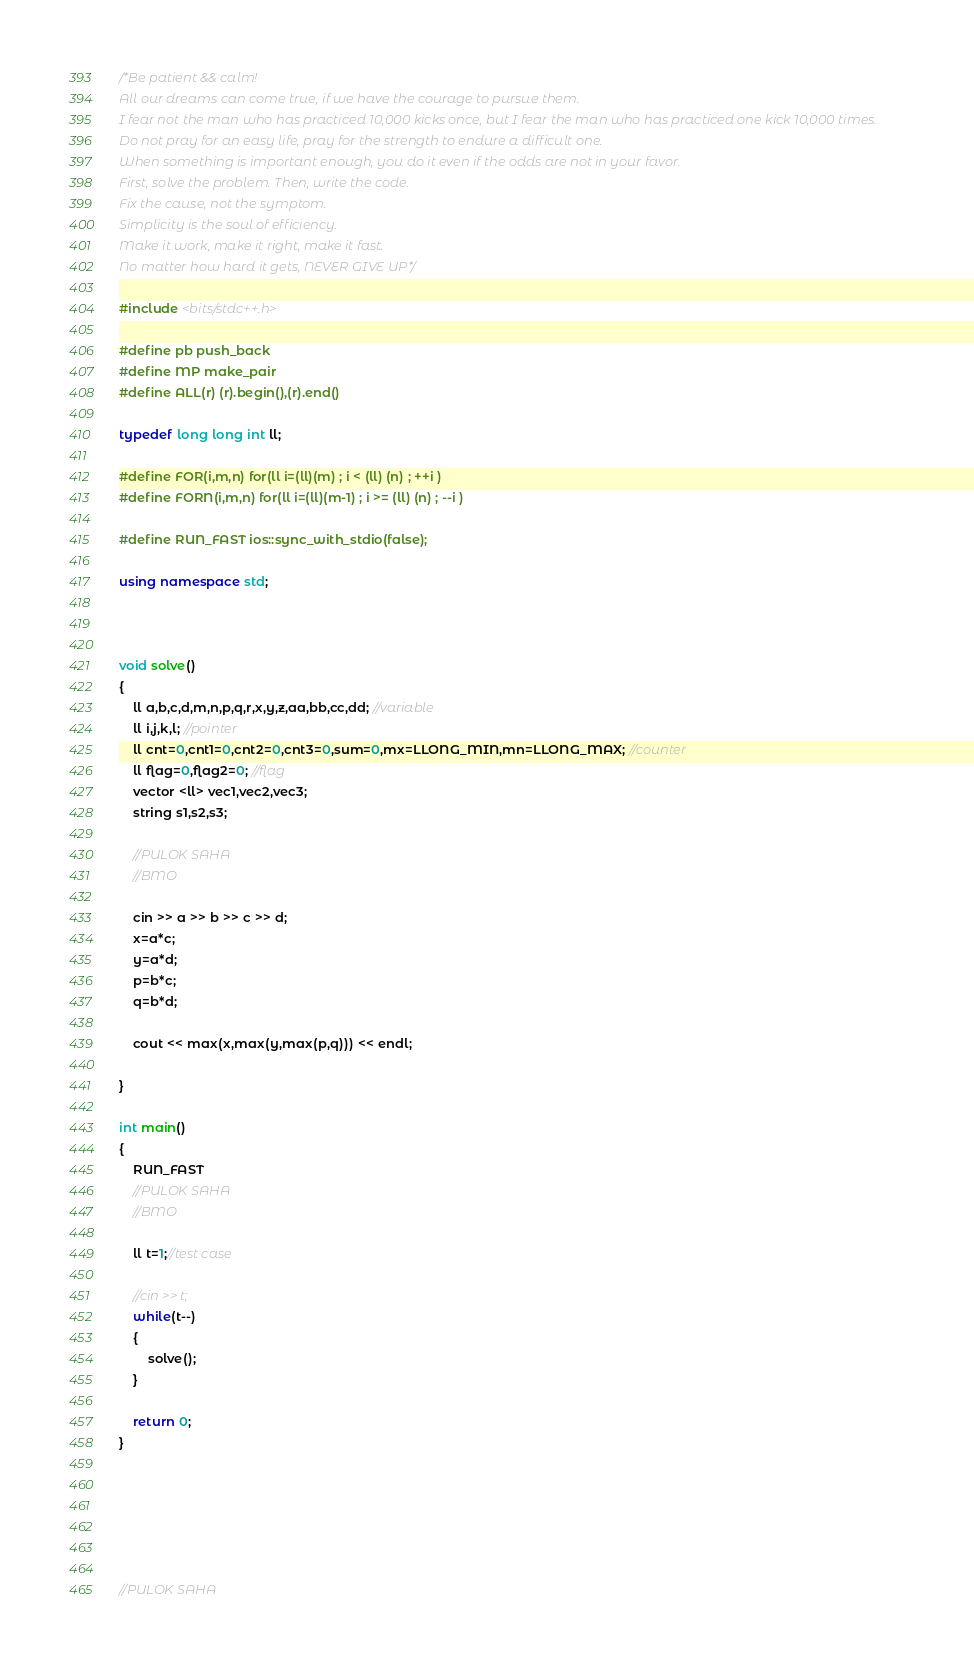Convert code to text. <code><loc_0><loc_0><loc_500><loc_500><_C++_>/*Be patient && calm!
All our dreams can come true, if we have the courage to pursue them.
I fear not the man who has practiced 10,000 kicks once, but I fear the man who has practiced one kick 10,000 times.
Do not pray for an easy life, pray for the strength to endure a difficult one.
When something is important enough, you do it even if the odds are not in your favor.
First, solve the problem. Then, write the code.
Fix the cause, not the symptom.
Simplicity is the soul of efficiency.
Make it work, make it right, make it fast.
No matter how hard it gets, NEVER GIVE UP*/

#include <bits/stdc++.h>

#define pb push_back
#define MP make_pair
#define ALL(r) (r).begin(),(r).end()

typedef long long int ll;

#define FOR(i,m,n) for(ll i=(ll)(m) ; i < (ll) (n) ; ++i )
#define FORN(i,m,n) for(ll i=(ll)(m-1) ; i >= (ll) (n) ; --i )

#define RUN_FAST ios::sync_with_stdio(false);

using namespace std;



void solve()
{
    ll a,b,c,d,m,n,p,q,r,x,y,z,aa,bb,cc,dd; //variable
    ll i,j,k,l; //pointer
    ll cnt=0,cnt1=0,cnt2=0,cnt3=0,sum=0,mx=LLONG_MIN,mn=LLONG_MAX; //counter
    ll flag=0,flag2=0; //flag
    vector <ll> vec1,vec2,vec3;
    string s1,s2,s3;

    //PULOK SAHA
    //BMO

    cin >> a >> b >> c >> d;
    x=a*c;
    y=a*d;
    p=b*c;
    q=b*d;

    cout << max(x,max(y,max(p,q))) << endl;

}

int main()
{
    RUN_FAST
    //PULOK SAHA
    //BMO

    ll t=1;//test case

    //cin >> t;
    while(t--)
    {
        solve();
    }

    return 0;
}






//PULOK SAHA</code> 